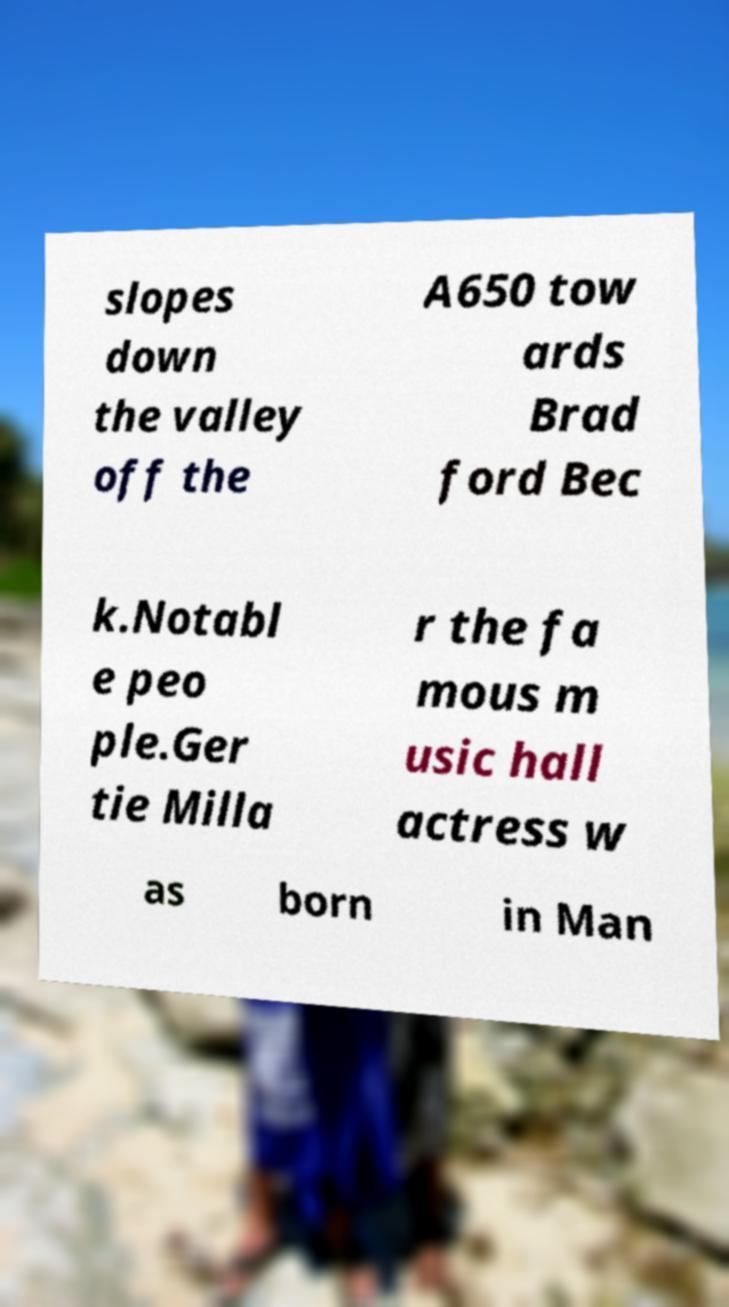I need the written content from this picture converted into text. Can you do that? slopes down the valley off the A650 tow ards Brad ford Bec k.Notabl e peo ple.Ger tie Milla r the fa mous m usic hall actress w as born in Man 